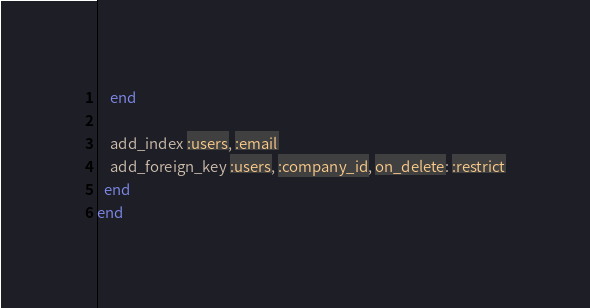<code> <loc_0><loc_0><loc_500><loc_500><_Ruby_>    end

    add_index :users, :email
    add_foreign_key :users, :company_id, on_delete: :restrict
  end
end
</code> 